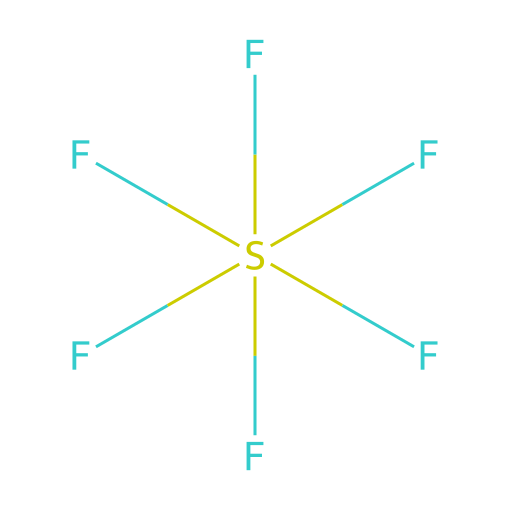What is the molecular formula of this chemical? The chemical is represented by the SMILES notation F[S](F)(F)(F)(F)F, indicating it consists of one sulfur atom (S) and six fluorine atoms (F). Therefore, the molecular formula can be deduced as SF6.
Answer: SF6 How many bonds are in this chemical structure? Each fluorine atom is connected to the sulfur atom via a single bond, and since there are six fluorine atoms, there are a total of six bonds in the structure.
Answer: 6 Is this compound a gas at room temperature? Sulfur hexafluoride is known to be a gas at room temperature, specifically due to its low boiling point of -64 degrees Celsius, making it gaseous under standard conditions.
Answer: yes What type of bonding is present in sulfur hexafluoride? The structure shows that sulfur (S) is bonded to fluorine (F) atoms through covalent single bonds, which is characteristic of the interactions in this molecule.
Answer: covalent What is the primary use of sulfur hexafluoride? Sulfur hexafluoride is predominantly used as an insulating gas in high-voltage electrical equipment due to its excellent dielectric properties.
Answer: insulating gas Does sulfur hexafluoride have any significant greenhouse gas potential? Yes, sulfur hexafluoride is a potent greenhouse gas with a high global warming potential due to its long atmospheric lifespan and effectiveness in trapping heat.
Answer: yes What is the odor characteristic of this compound? Sulfur hexafluoride is known to be odorless, meaning it does not have a noticeable smell, which is important for safety considerations in its usage.
Answer: odorless 